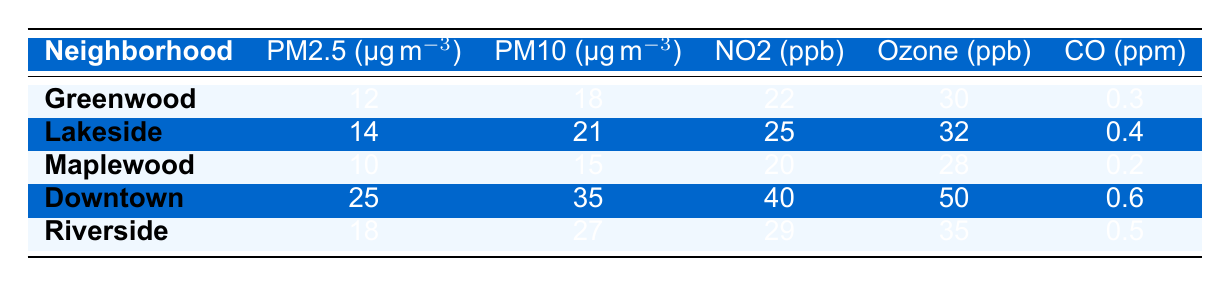What is the PM2.5 level in Downtown? The PM2.5 value for Downtown is located in the respective row under the PM2.5 column, which shows a value of 25 µg/m³.
Answer: 25 µg/m³ Which neighborhood has the highest NO2 level? By examining the NO2 values in the table, Downtown has the highest NO2 level of 40 ppb among all the neighborhoods listed.
Answer: Downtown What is the average PM10 level across all neighborhoods? The PM10 values for the neighborhoods are: 18, 21, 15, 35, and 27. Summing these gives 18 + 21 + 15 + 35 + 27 = 116. Dividing by 5 neighborhoods gives an average of 116/5 = 23.2 µg/m³.
Answer: 23.2 µg/m³ Is the Ozone level in Maplewood higher than in Greenwood? The Ozone level for Maplewood is 28 ppb, while for Greenwood it is 30 ppb. Therefore, the Ozone level in Maplewood is not higher than in Greenwood.
Answer: No What is the difference in PM2.5 levels between Downtown and Riverside? The PM2.5 level in Downtown is 25 µg/m³, and in Riverside, it is 18 µg/m³. The difference is 25 - 18 = 7 µg/m³.
Answer: 7 µg/m³ Which neighborhood has the lowest CO level? Looking at the CO levels in the table, Maplewood has the lowest CO level at 0.2 ppm.
Answer: Maplewood What is the total level of PM2.5 across all neighborhoods? The PM2.5 levels are 12, 14, 10, 25, and 18. Adding these together gives 12 + 14 + 10 + 25 + 18 = 89 µg/m³.
Answer: 89 µg/m³ Is the PM10 pollution level in Lakeside lower than in Riverside? The PM10 level for Lakeside is 21 µg/m³, while for Riverside, it is 27 µg/m³. Thus, Lakeside has a lower PM10 level.
Answer: Yes What is the highest Ozone value recorded in the table? Upon reviewing the Ozone column, Downtown has the highest value of 50 ppb.
Answer: 50 ppb 